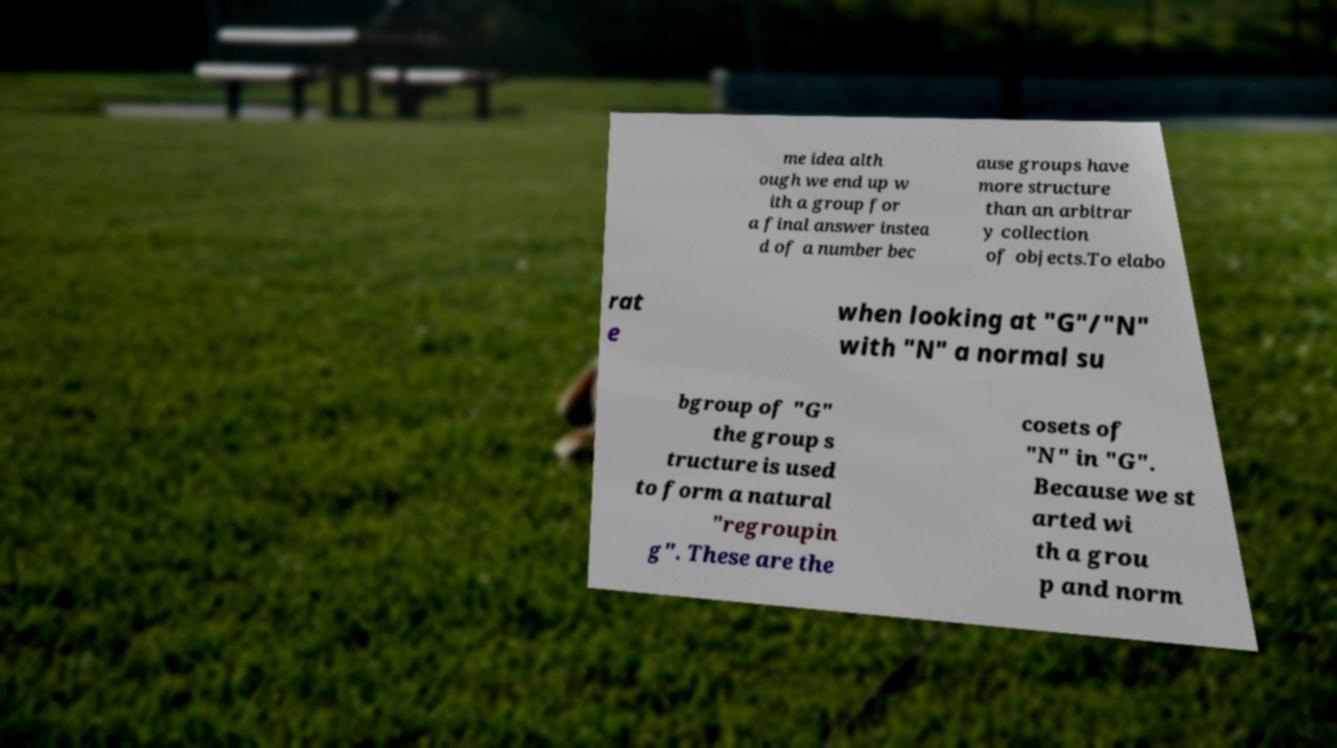There's text embedded in this image that I need extracted. Can you transcribe it verbatim? me idea alth ough we end up w ith a group for a final answer instea d of a number bec ause groups have more structure than an arbitrar y collection of objects.To elabo rat e when looking at "G"/"N" with "N" a normal su bgroup of "G" the group s tructure is used to form a natural "regroupin g". These are the cosets of "N" in "G". Because we st arted wi th a grou p and norm 